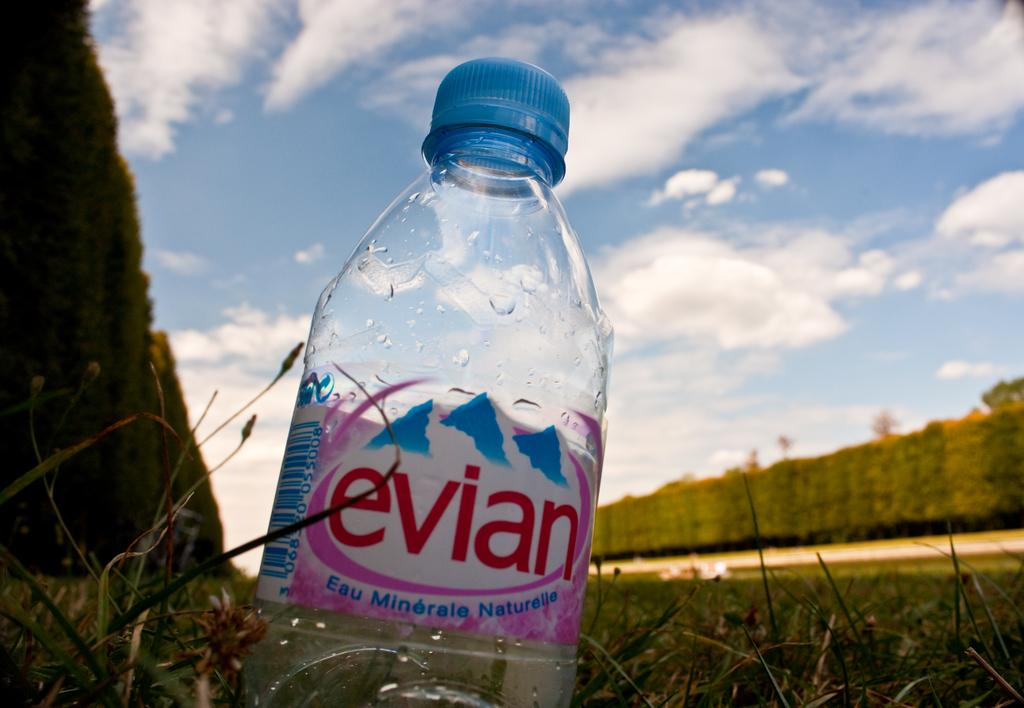What is the main focus of the picture? The bottle is highlighted in the picture. How would you describe the weather based on the image? The sky is cloudy in the image. What color is the cap of the bottle? The bottle has a blue cap. Are there any additional features on the bottle? Yes, the bottle has a sticker. What type of vegetation can be seen in the image? There are plants and grass visible in the image. How does the person in the image react to their fear of haircuts? There is no person present in the image, and therefore no reaction to fear of haircuts can be observed. What type of basin is used to collect water from the plants in the image? There is no basin present in the image; the plants are not being watered. 